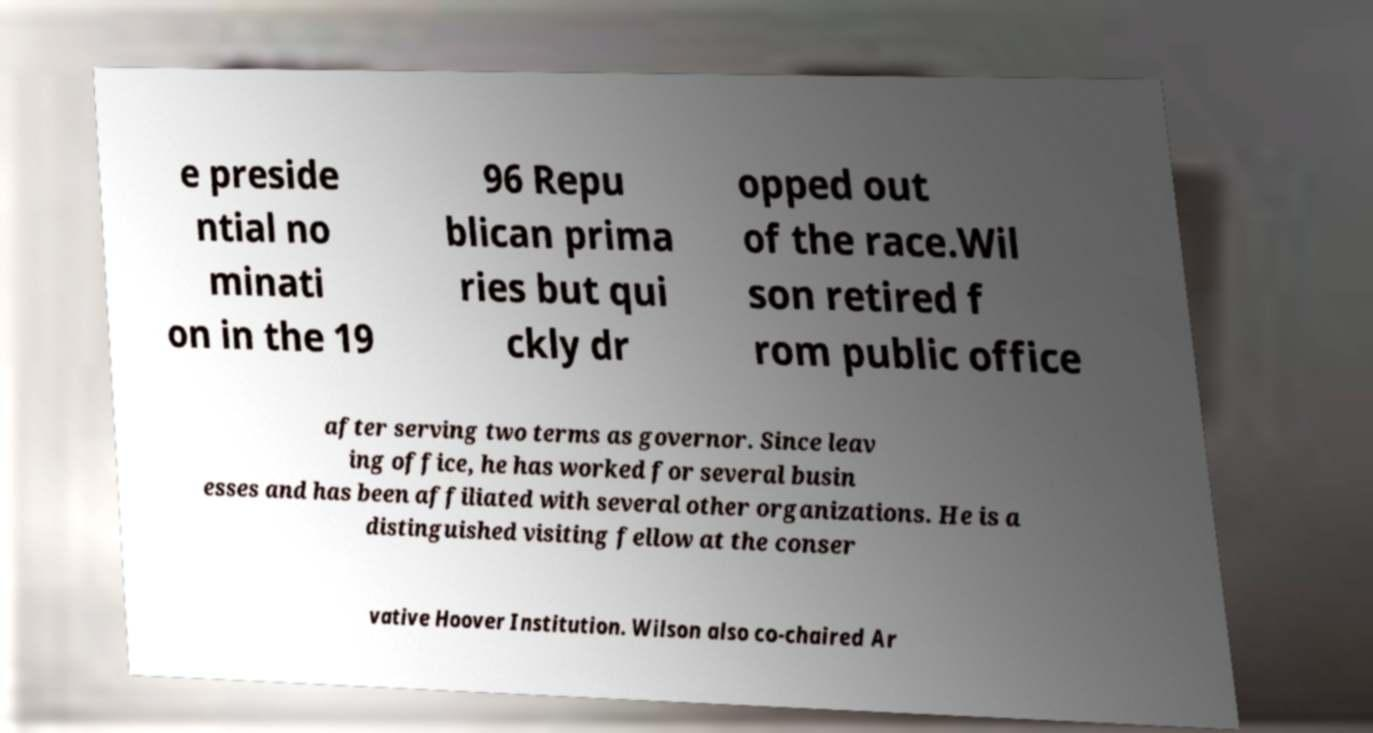I need the written content from this picture converted into text. Can you do that? e preside ntial no minati on in the 19 96 Repu blican prima ries but qui ckly dr opped out of the race.Wil son retired f rom public office after serving two terms as governor. Since leav ing office, he has worked for several busin esses and has been affiliated with several other organizations. He is a distinguished visiting fellow at the conser vative Hoover Institution. Wilson also co-chaired Ar 